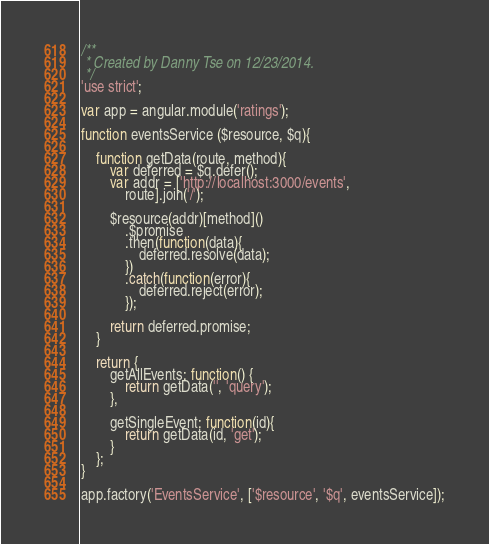Convert code to text. <code><loc_0><loc_0><loc_500><loc_500><_JavaScript_>/**
 * Created by Danny Tse on 12/23/2014.
 */
'use strict';

var app = angular.module('ratings');

function eventsService ($resource, $q){

    function getData(route, method){
        var deferred = $q.defer();
        var addr = ['http://localhost:3000/events',
            route].join('/');

        $resource(addr)[method]()
            .$promise
            .then(function(data){
                deferred.resolve(data);
            })
            .catch(function(error){
                deferred.reject(error);
            });

        return deferred.promise;
    }

    return {
        getAllEvents: function() {
            return getData('', 'query');
        },

        getSingleEvent: function(id){
            return getData(id, 'get');
        }
    };
}

app.factory('EventsService', ['$resource', '$q', eventsService]);

</code> 